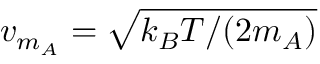Convert formula to latex. <formula><loc_0><loc_0><loc_500><loc_500>v _ { m _ { A } } = \sqrt { k _ { B } T / ( 2 m _ { A } ) }</formula> 